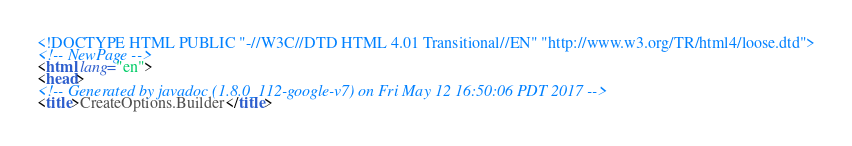<code> <loc_0><loc_0><loc_500><loc_500><_HTML_><!DOCTYPE HTML PUBLIC "-//W3C//DTD HTML 4.01 Transitional//EN" "http://www.w3.org/TR/html4/loose.dtd">
<!-- NewPage -->
<html lang="en">
<head>
<!-- Generated by javadoc (1.8.0_112-google-v7) on Fri May 12 16:50:06 PDT 2017 -->
<title>CreateOptions.Builder</title></code> 